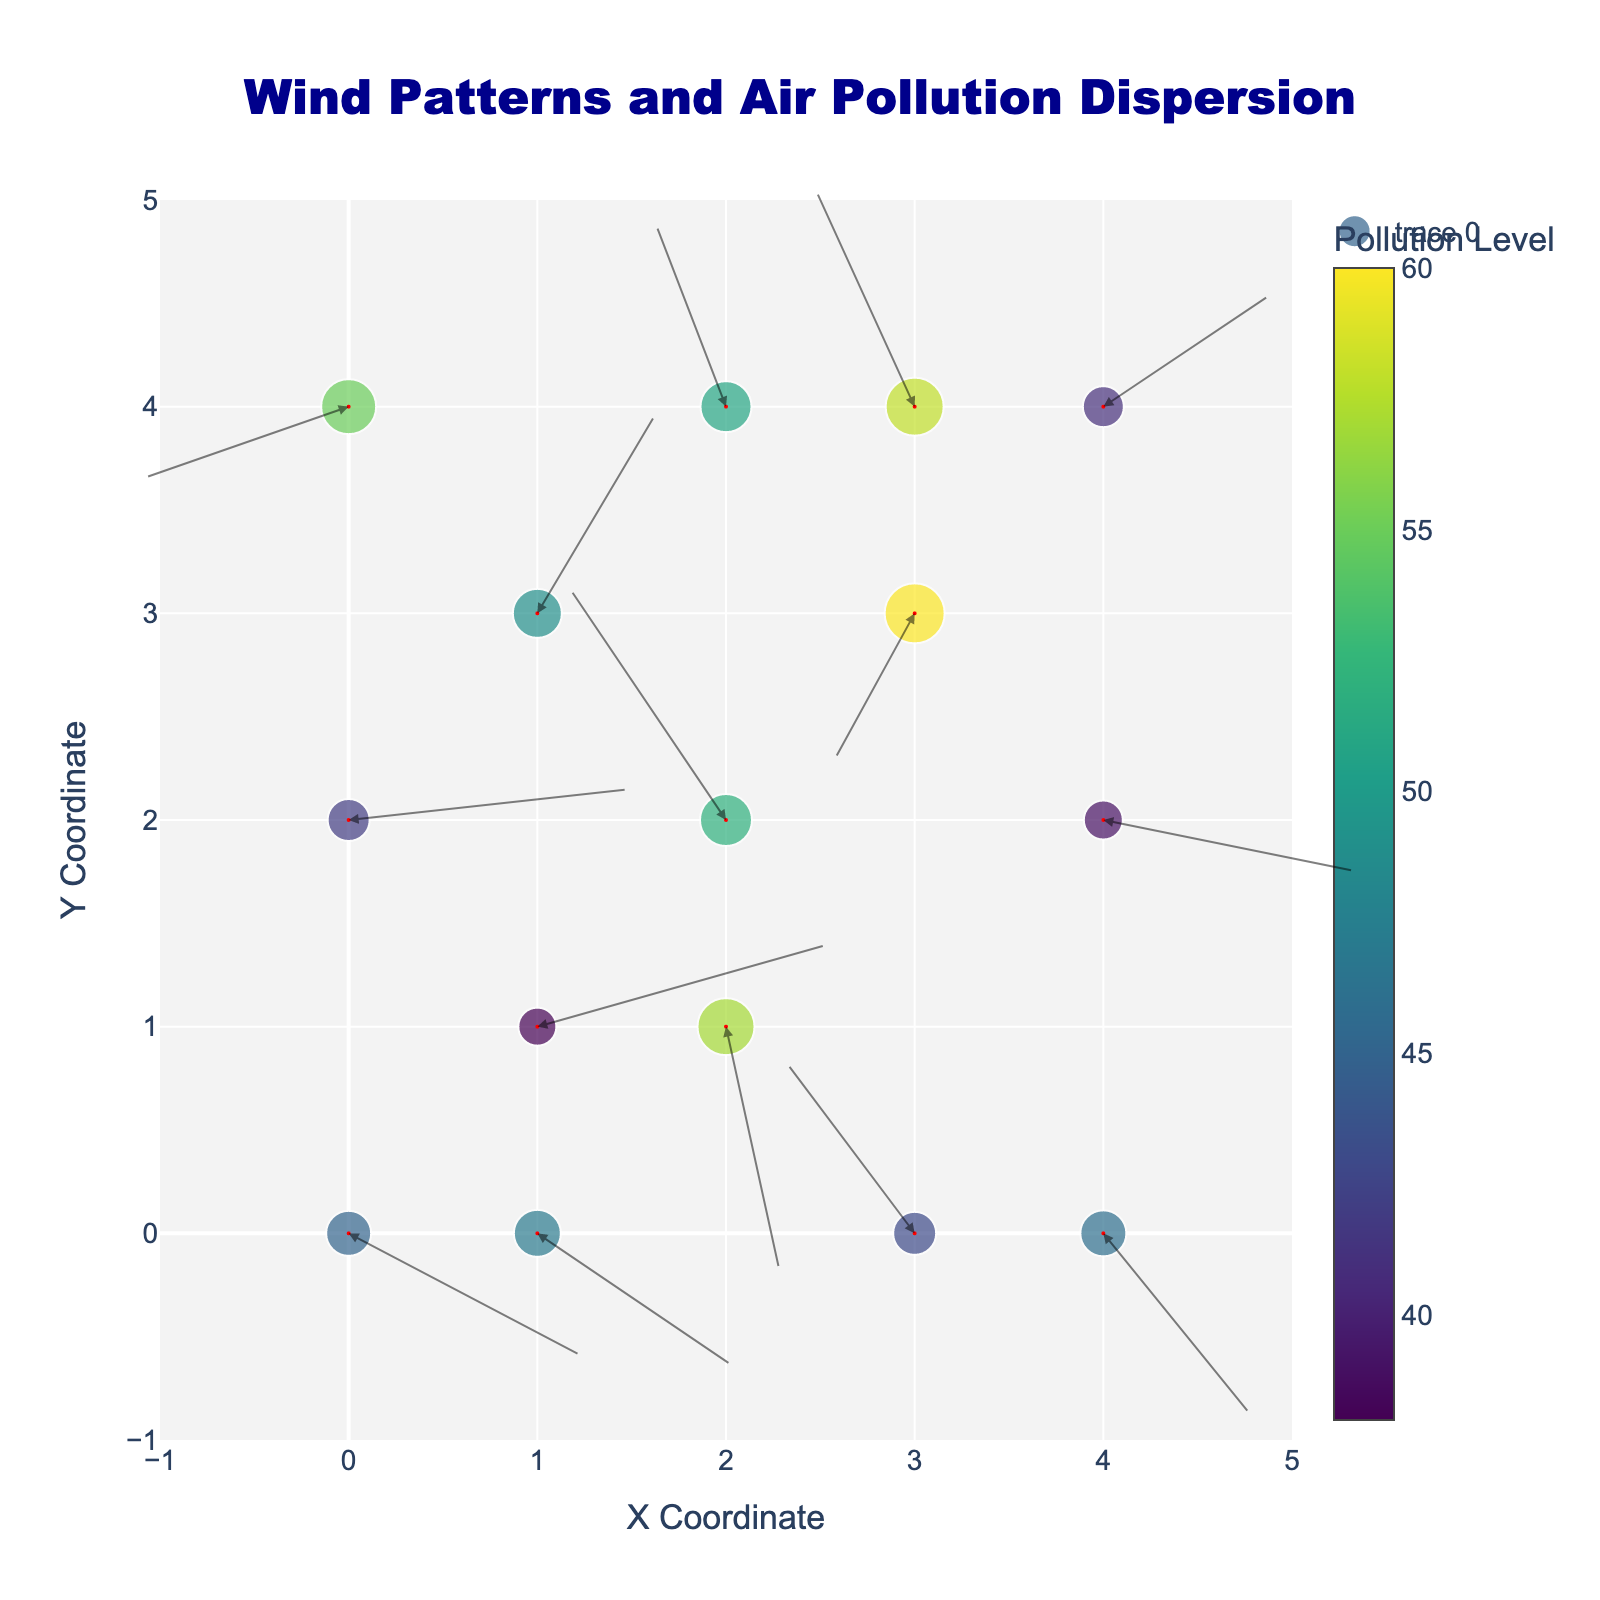What is the title of the figure? The title is usually displayed at the top of the figure, and it is written as a descriptive label summarizing the main message. The title of this figure is "Wind Patterns and Air Pollution Dispersion".
Answer: Wind Patterns and Air Pollution Dispersion How many arrows are displayed in the figure? By counting the arrows present in the figure, which represent the wind vectors, it is evident that there are 15 arrows.
Answer: 15 What color map is used for the pollution levels? The color map can be identified by the visual gradient used to represent the pollution levels. In this figure, the 'Viridis' color scale is used which ranges from purple to yellow.
Answer: Viridis What is the average pollution level in the figure? To find the average pollution level, sum all the pollution levels: 45 + 38 + 52 + 60 + 41 + 55 + 49 + 57 + 43 + 39 + 51 + 46 + 42 + 58 + 47 = 723. There are 15 data points, so the average is 723/15 = 48.2.
Answer: 48.2 What is the range of the x-axis and y-axis in the figure? The range of an axis is determined by the minimum and maximum values displayed. In this figure, the x-axis and y-axis both range from -1 to 5.
Answer: -1 to 5 Which data point has the highest pollution level and what is that value? By identifying the data point with the highest value in the pollution_level column, it is the one with the value 60. This occurs at (x=3, y=3).
Answer: 60 Which area shows the strongest wind vector? The strength of the wind vector can be assessed by the arrow length, calculated by sqrt(u^2 + v^2). The wind vector (3.1, 0.8) at (x=1, y=1) has the strongest value: sqrt(3.1^2 + 0.8^2) = sqrt(10.41) = 3.23.
Answer: (1, 1) What is represented by the arrows in the figure? The arrows in a quiver plot represent the wind vectors, showing both the direction and magnitude of the wind at each point in the figure.
Answer: Wind vectors Are there arrows that point west and have high pollution levels associated with them? To identify arrows pointing west, look for negative u values, such as (2,2) with arrow (-1.7, 2.3) and (2,4) with arrow (-0.8, 1.9), both having pollution levels of 52 and 51, respectively.
Answer: Yes 